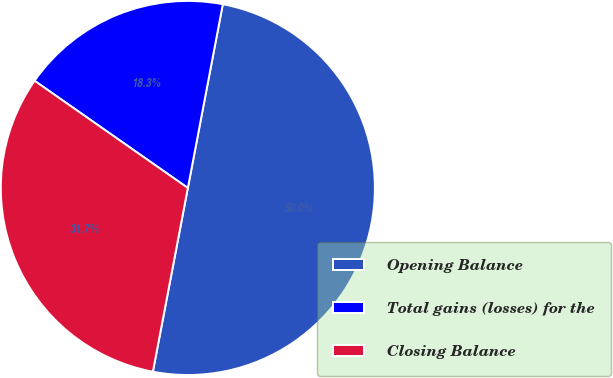Convert chart. <chart><loc_0><loc_0><loc_500><loc_500><pie_chart><fcel>Opening Balance<fcel>Total gains (losses) for the<fcel>Closing Balance<nl><fcel>50.0%<fcel>18.28%<fcel>31.72%<nl></chart> 